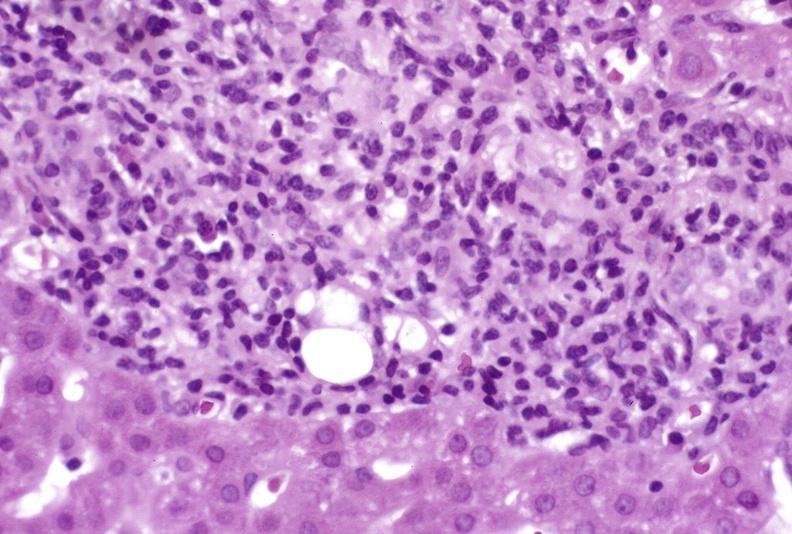s liver present?
Answer the question using a single word or phrase. Yes 